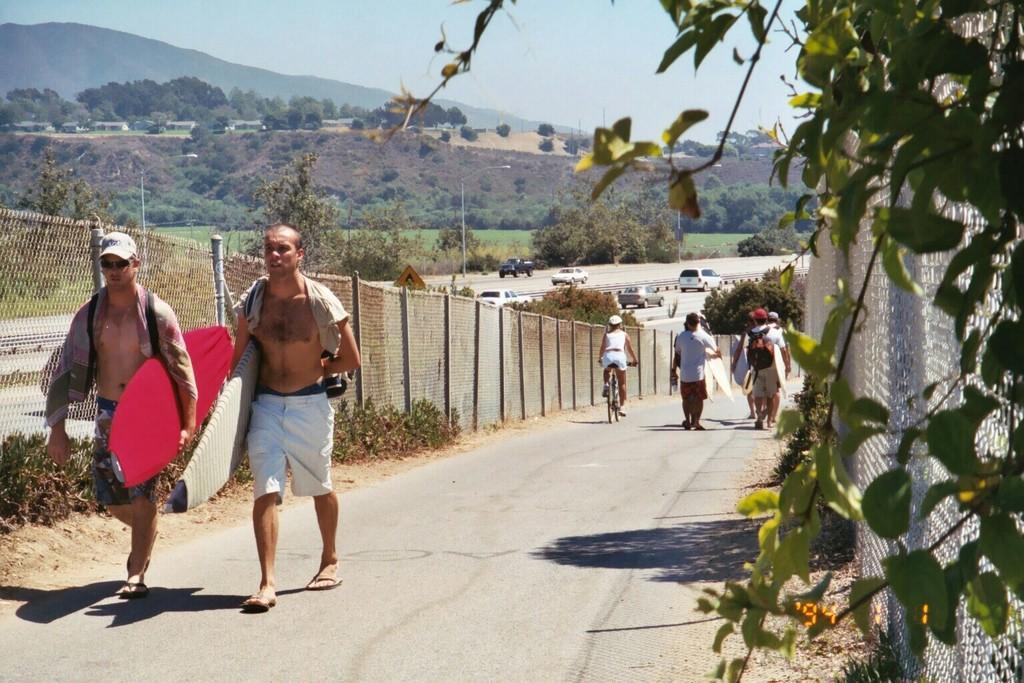Please provide a concise description of this image. In the image we can see there are people who are standing on the road and holding a surfing board in the hand and another guy is sitting on the bicycle and there is a clear sky and the cars are standing on the road and there are lot of trees. 